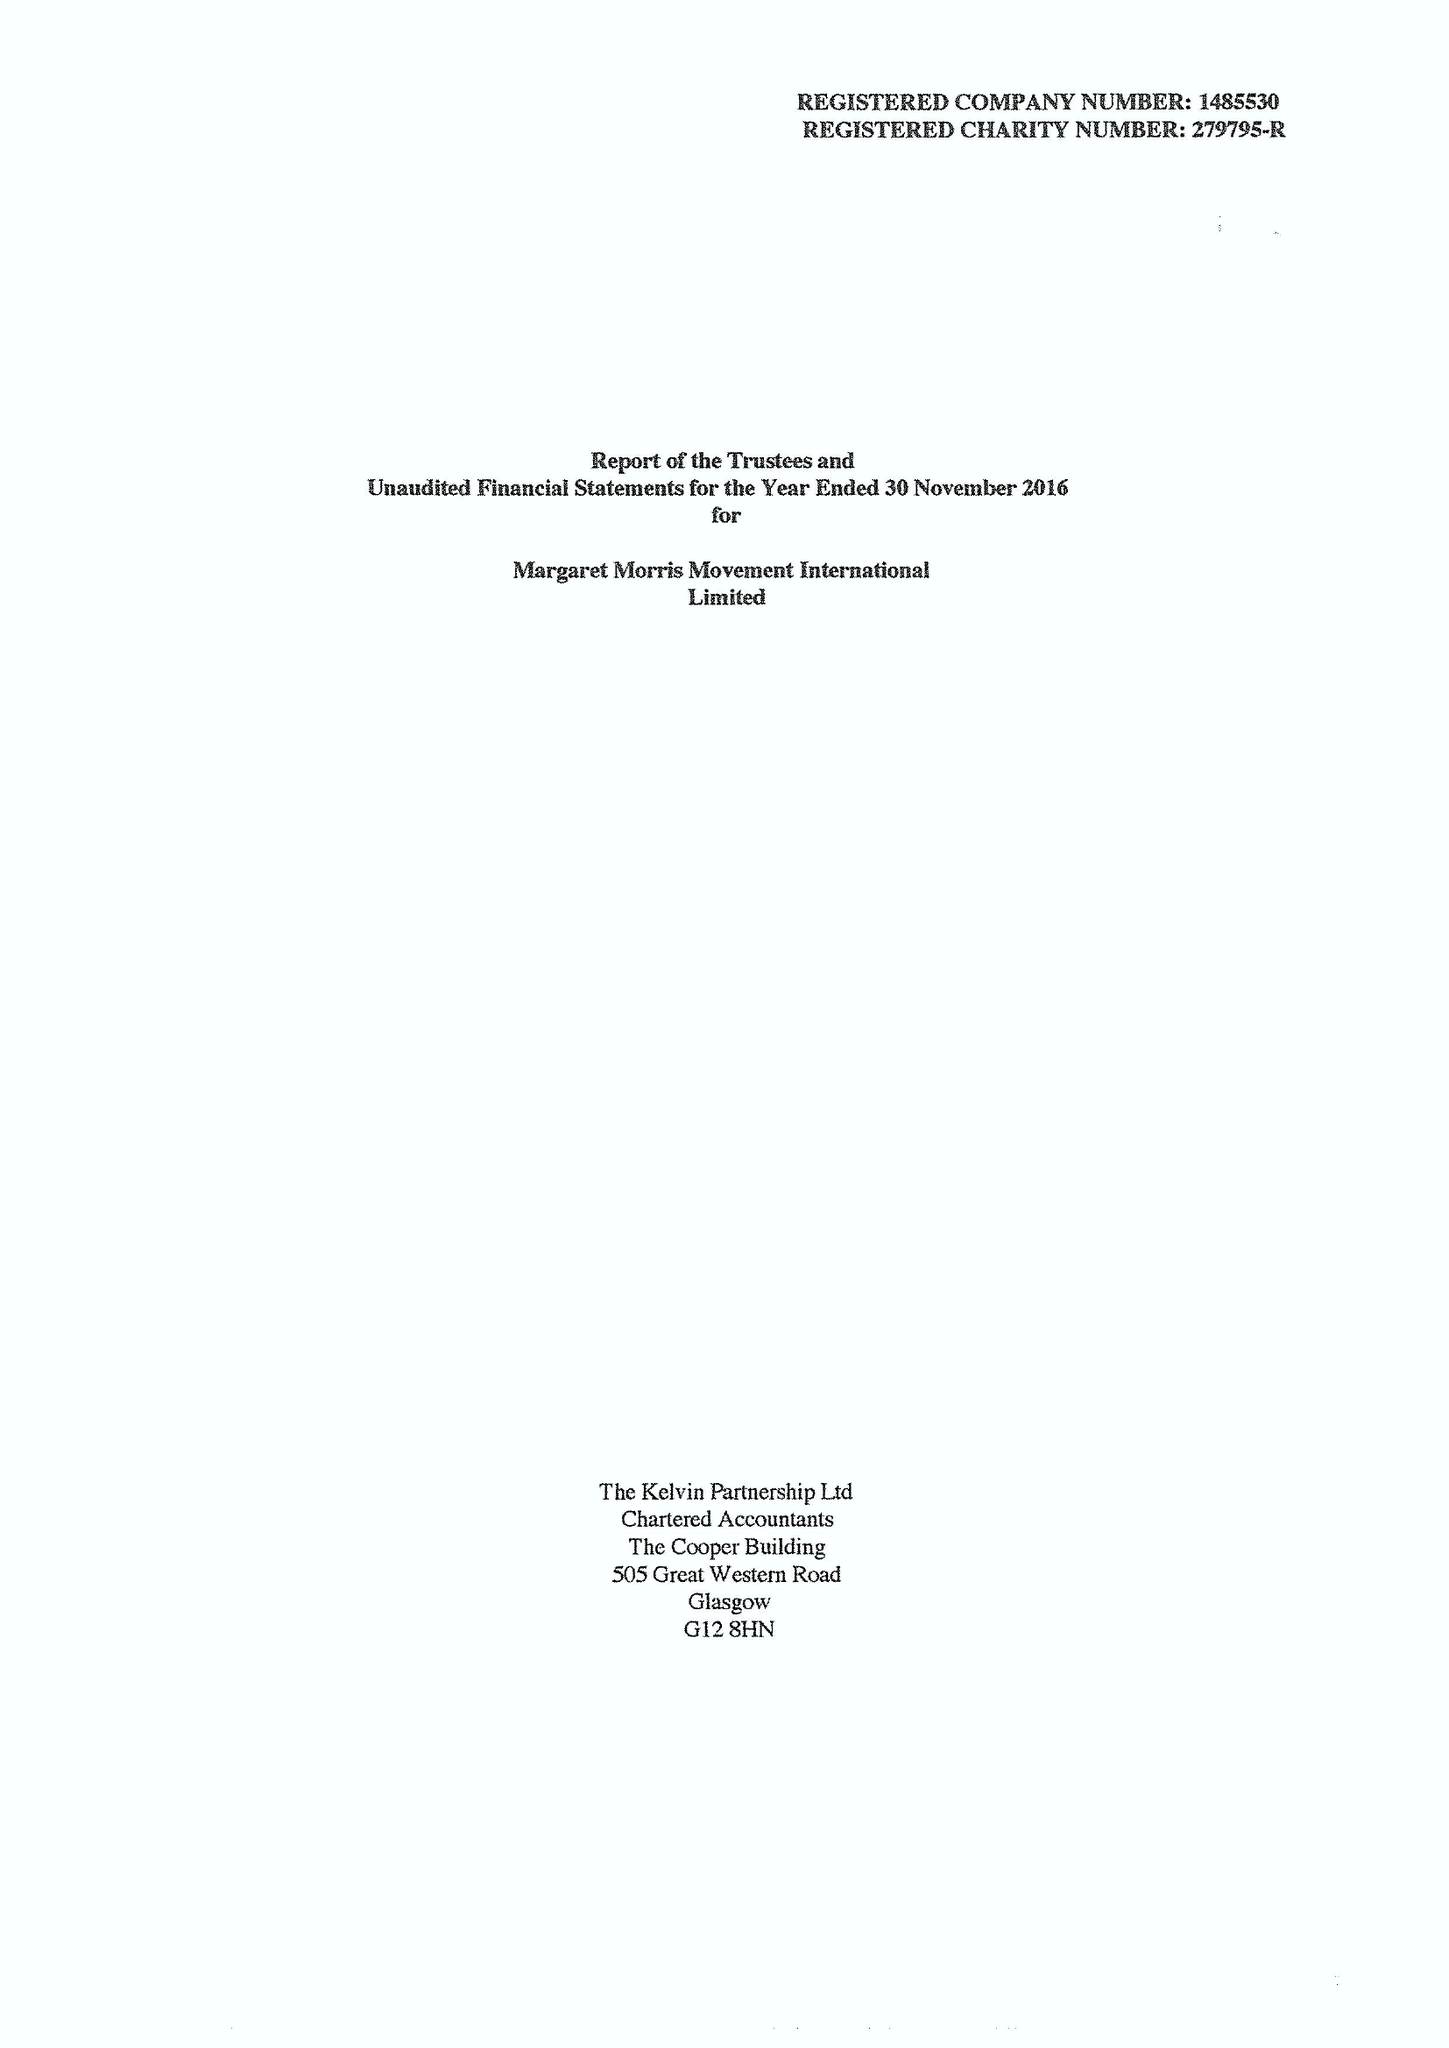What is the value for the address__post_town?
Answer the question using a single word or phrase. TELFORD 